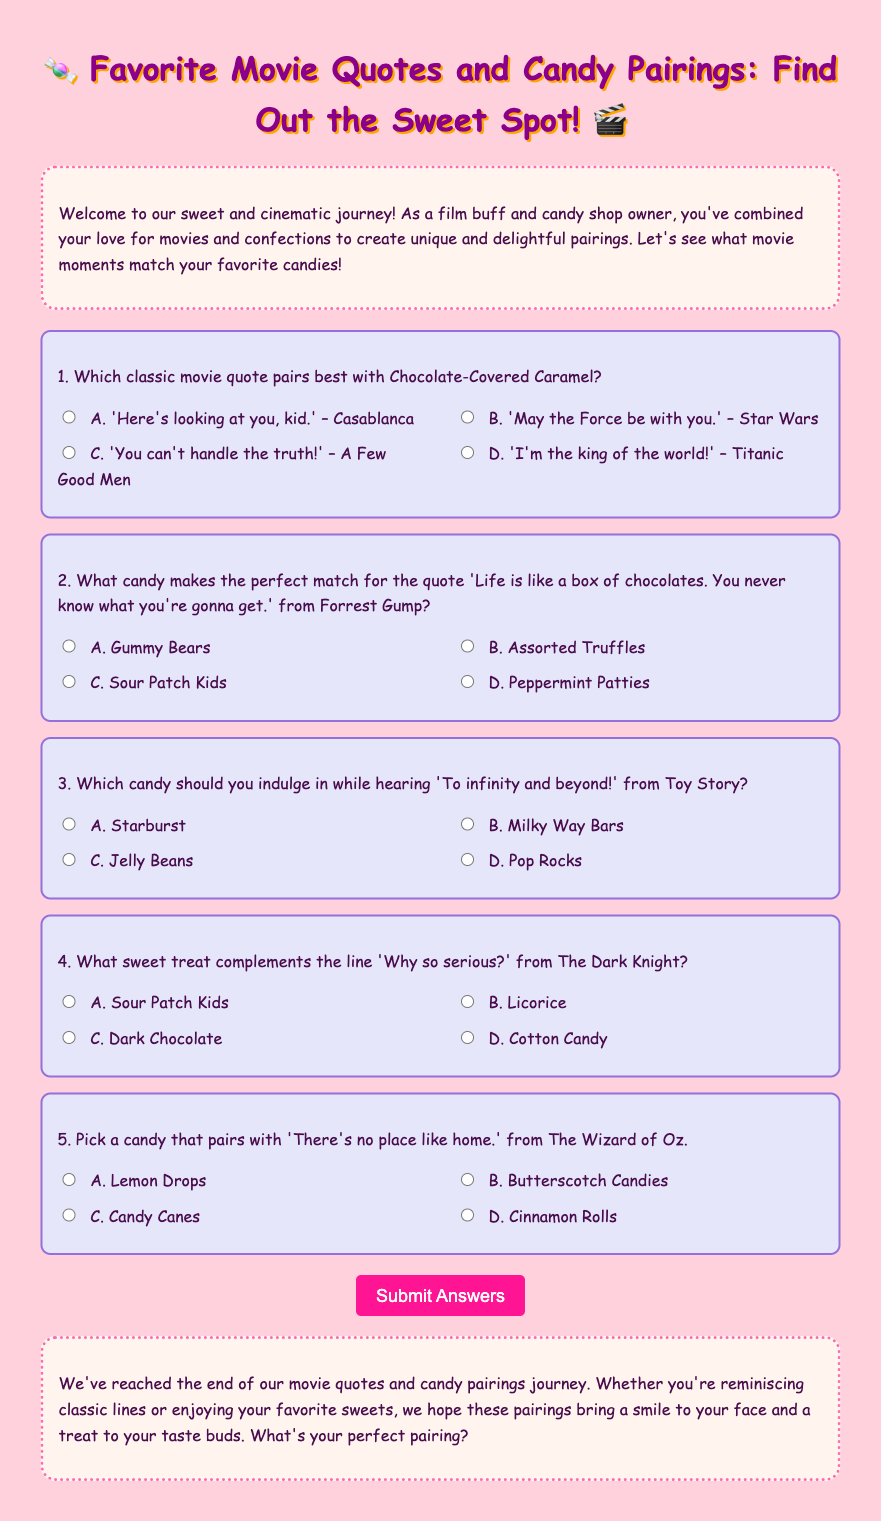What is the title of the quiz? The title of the quiz is prominently displayed in the heading of the document, which is aimed at favorite movie quotes and candy pairings.
Answer: Favorite Movie Quotes and Candy Pairings: Find Out the Sweet Spot! How many questions are in the quiz? The quiz consists of a section with five distinct questions related to movie quotes and candy.
Answer: 5 What color is the background of the web page? The background color of the web page is set in the CSS styling section of the document.
Answer: #FFD1DC Which movie quote is paired with Chocolate-Covered Caramel? The document lists a specific movie quote that pairs best with each candy, and the first question mentions one of those pairings.
Answer: 'Here's looking at you, kid.' – Casablanca What sweet treat complements the line 'Why so serious?' This specific question is designed to make a connection between a popular quote and an appropriate candy.
Answer: Dark Chocolate What is the correct answer for the candy that goes with the quote from Forrest Gump? The answer corresponds to the question about which candy matches the famous quote, providing options for selection.
Answer: Assorted Truffles What will you see when you submit the quiz? Submitting the quiz will result in a score display that reflects how many answers were correct.
Answer: You got [score] out of 5 correct! What is the background color of the conclusion section? The background color for the conclusion section is specifically mentioned in the CSS, providing distinct visual separation.
Answer: #FFF5EE 